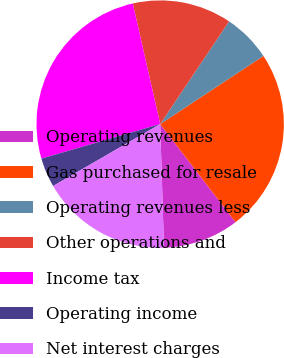Convert chart. <chart><loc_0><loc_0><loc_500><loc_500><pie_chart><fcel>Operating revenues<fcel>Gas purchased for resale<fcel>Operating revenues less<fcel>Other operations and<fcel>Income tax<fcel>Operating income<fcel>Net interest charges<nl><fcel>9.94%<fcel>23.86%<fcel>6.31%<fcel>12.96%<fcel>25.95%<fcel>3.84%<fcel>17.14%<nl></chart> 